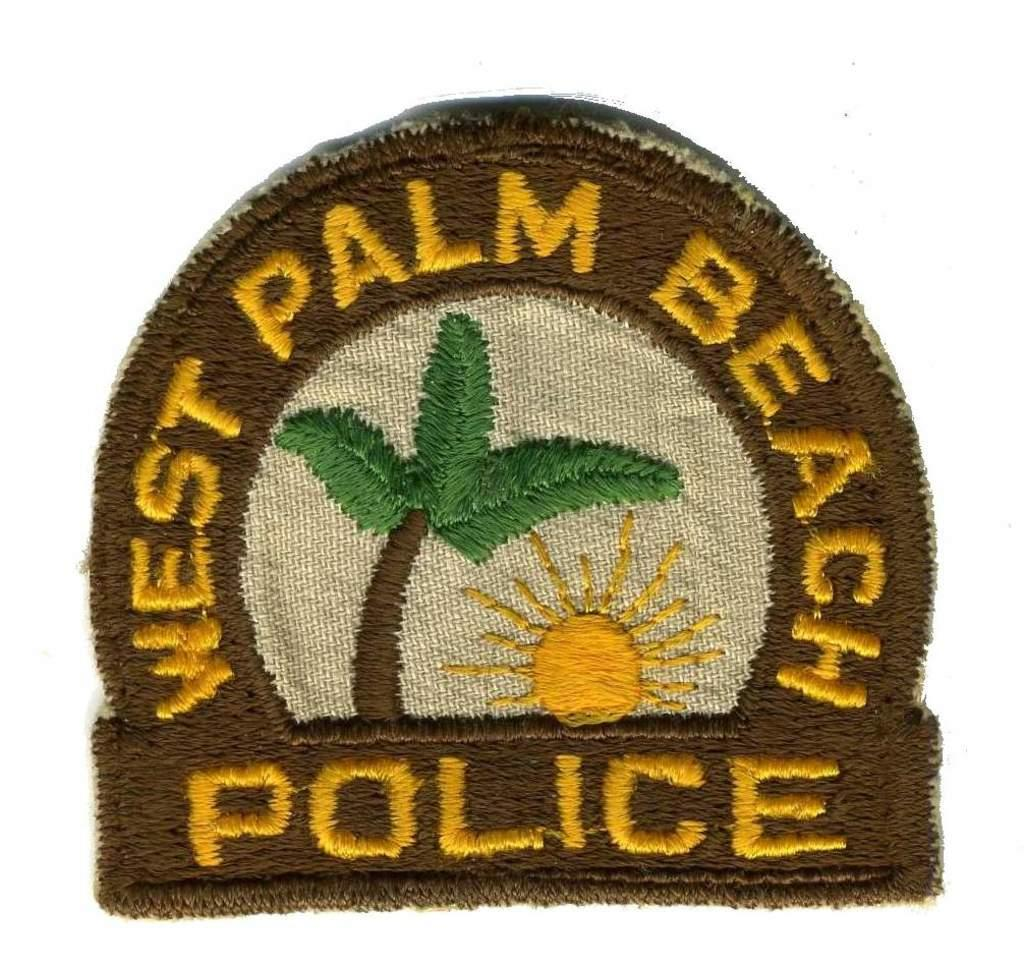<image>
Summarize the visual content of the image. A west palm beach police badge has rhe sun and a palm tree as its main focus. 